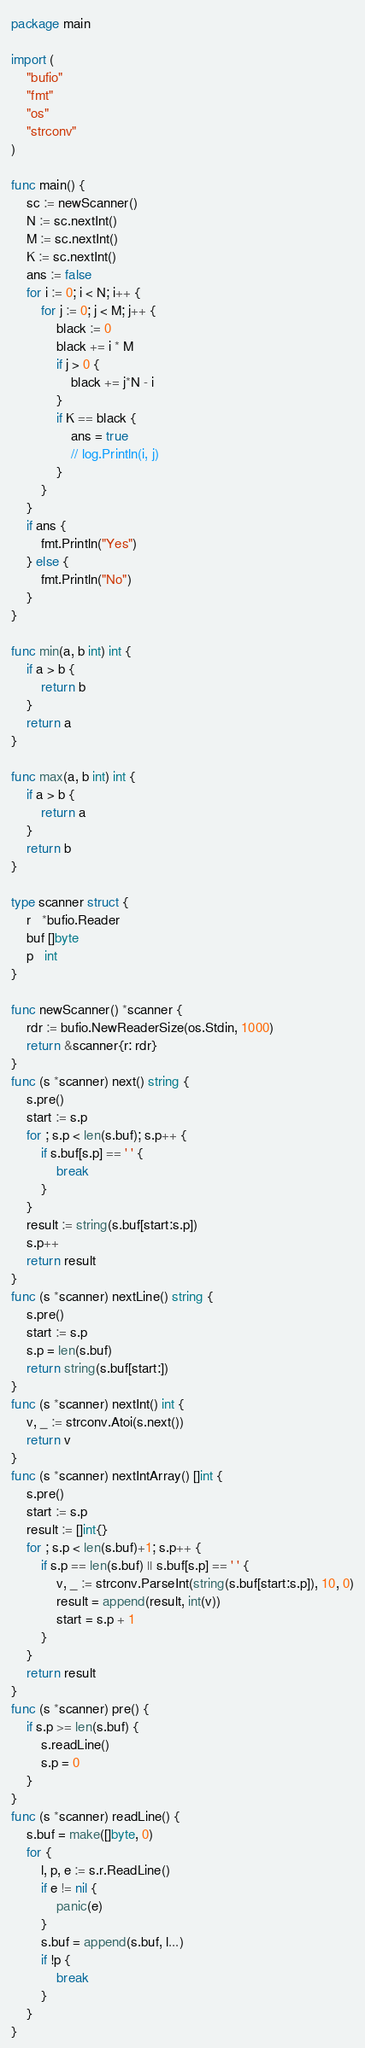Convert code to text. <code><loc_0><loc_0><loc_500><loc_500><_Go_>package main

import (
	"bufio"
	"fmt"
	"os"
	"strconv"
)

func main() {
	sc := newScanner()
	N := sc.nextInt()
	M := sc.nextInt()
	K := sc.nextInt()
	ans := false
	for i := 0; i < N; i++ {
		for j := 0; j < M; j++ {
			black := 0
			black += i * M
			if j > 0 {
				black += j*N - i
			}
			if K == black {
				ans = true
				// log.Println(i, j)
			}
		}
	}
	if ans {
		fmt.Println("Yes")
	} else {
		fmt.Println("No")
	}
}

func min(a, b int) int {
	if a > b {
		return b
	}
	return a
}

func max(a, b int) int {
	if a > b {
		return a
	}
	return b
}

type scanner struct {
	r   *bufio.Reader
	buf []byte
	p   int
}

func newScanner() *scanner {
	rdr := bufio.NewReaderSize(os.Stdin, 1000)
	return &scanner{r: rdr}
}
func (s *scanner) next() string {
	s.pre()
	start := s.p
	for ; s.p < len(s.buf); s.p++ {
		if s.buf[s.p] == ' ' {
			break
		}
	}
	result := string(s.buf[start:s.p])
	s.p++
	return result
}
func (s *scanner) nextLine() string {
	s.pre()
	start := s.p
	s.p = len(s.buf)
	return string(s.buf[start:])
}
func (s *scanner) nextInt() int {
	v, _ := strconv.Atoi(s.next())
	return v
}
func (s *scanner) nextIntArray() []int {
	s.pre()
	start := s.p
	result := []int{}
	for ; s.p < len(s.buf)+1; s.p++ {
		if s.p == len(s.buf) || s.buf[s.p] == ' ' {
			v, _ := strconv.ParseInt(string(s.buf[start:s.p]), 10, 0)
			result = append(result, int(v))
			start = s.p + 1
		}
	}
	return result
}
func (s *scanner) pre() {
	if s.p >= len(s.buf) {
		s.readLine()
		s.p = 0
	}
}
func (s *scanner) readLine() {
	s.buf = make([]byte, 0)
	for {
		l, p, e := s.r.ReadLine()
		if e != nil {
			panic(e)
		}
		s.buf = append(s.buf, l...)
		if !p {
			break
		}
	}
}
</code> 